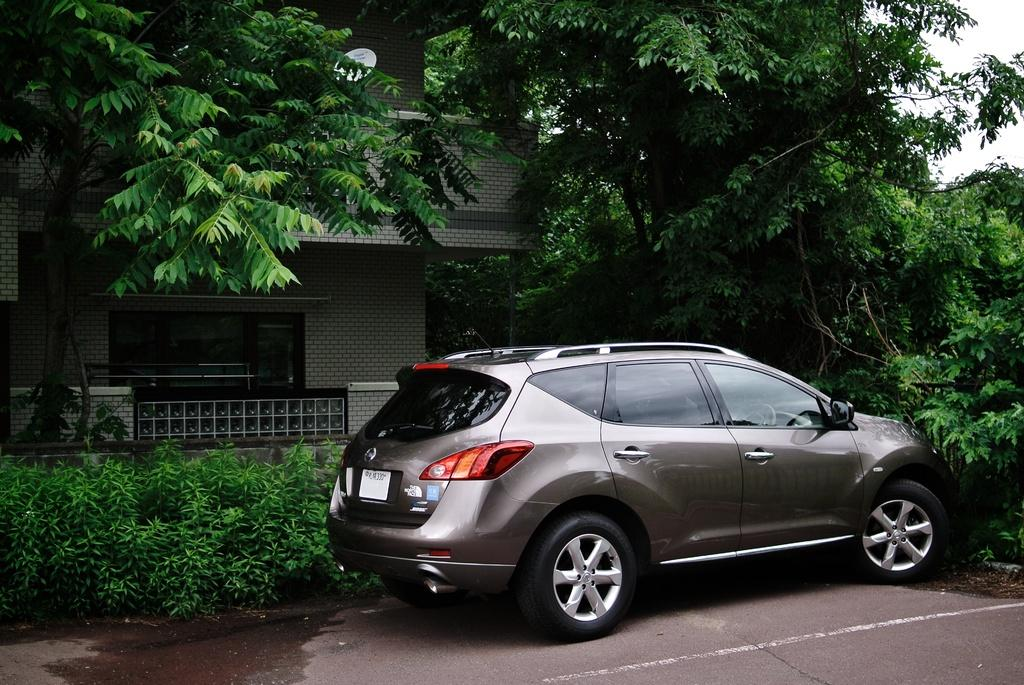What type of building is in the image? There is a building in the image, but the specific type cannot be determined from the facts provided. What else can be seen in the image besides the building? There is a car, a dish, trees, and plants visible in the image. Can you describe the dish in the image? The dish is visible at the top of the image, but its contents or purpose cannot be determined from the facts provided. What type of vegetation is present in the image? There are trees and plants in the image. What type of lettuce is being stored in the crate in the image? There is no crate or lettuce present in the image. Can you describe the elbow of the person in the image? There is no person present in the image, so there is no elbow to describe. 